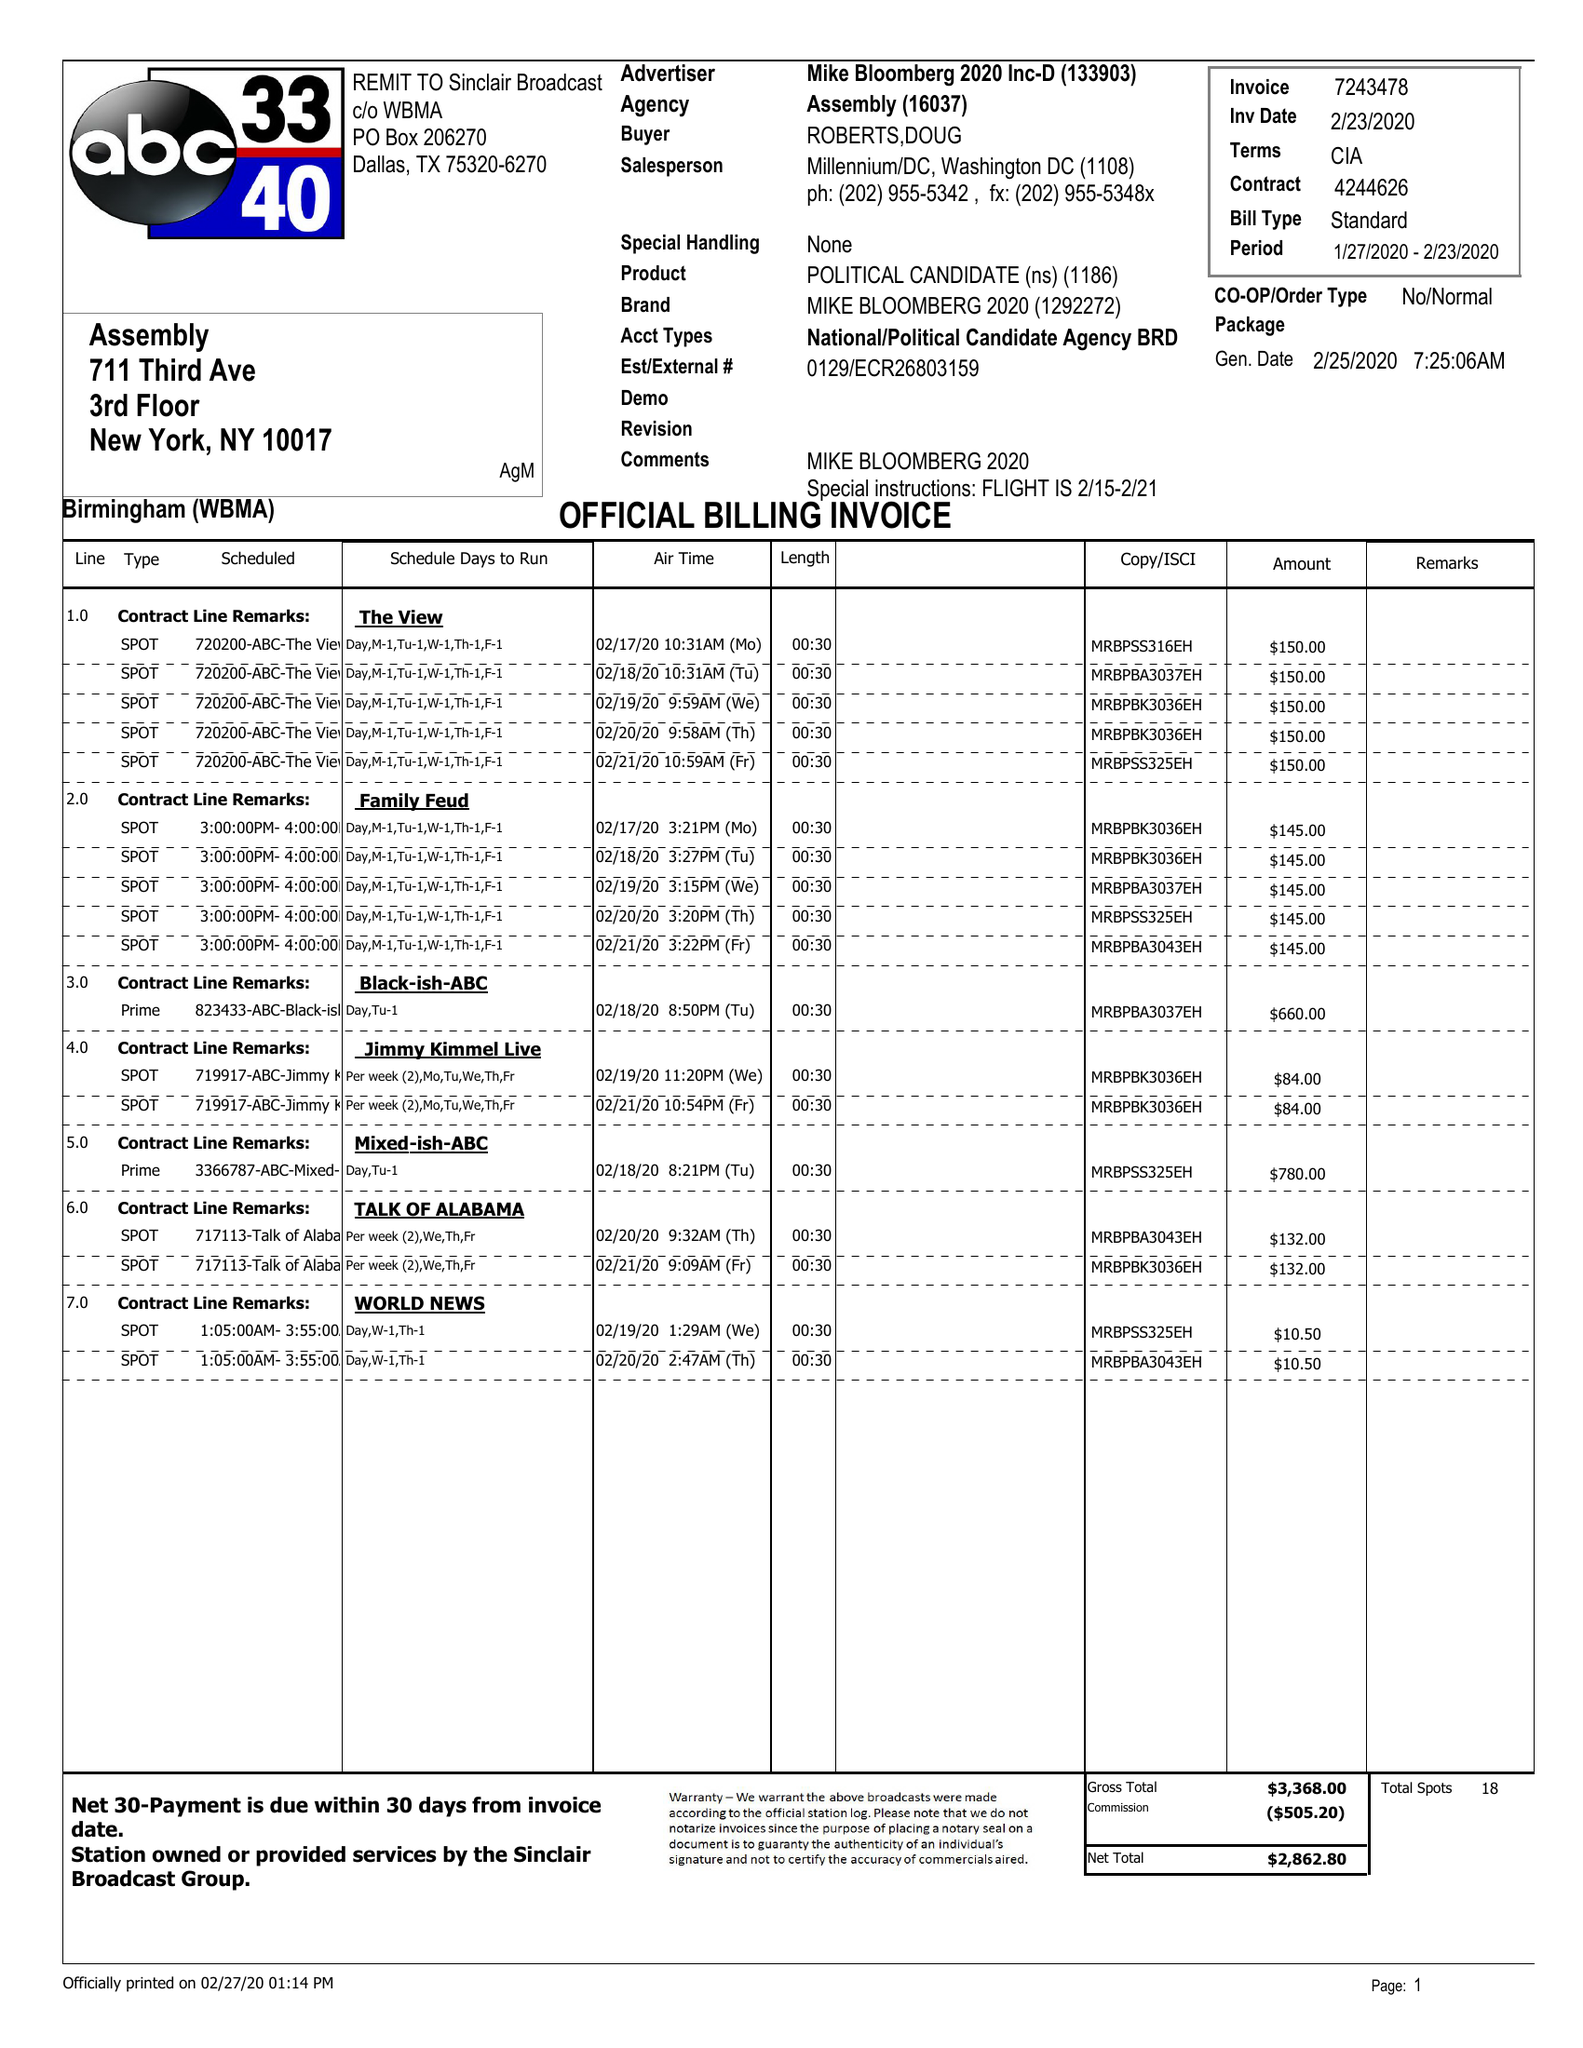What is the value for the flight_to?
Answer the question using a single word or phrase. 02/23/20 